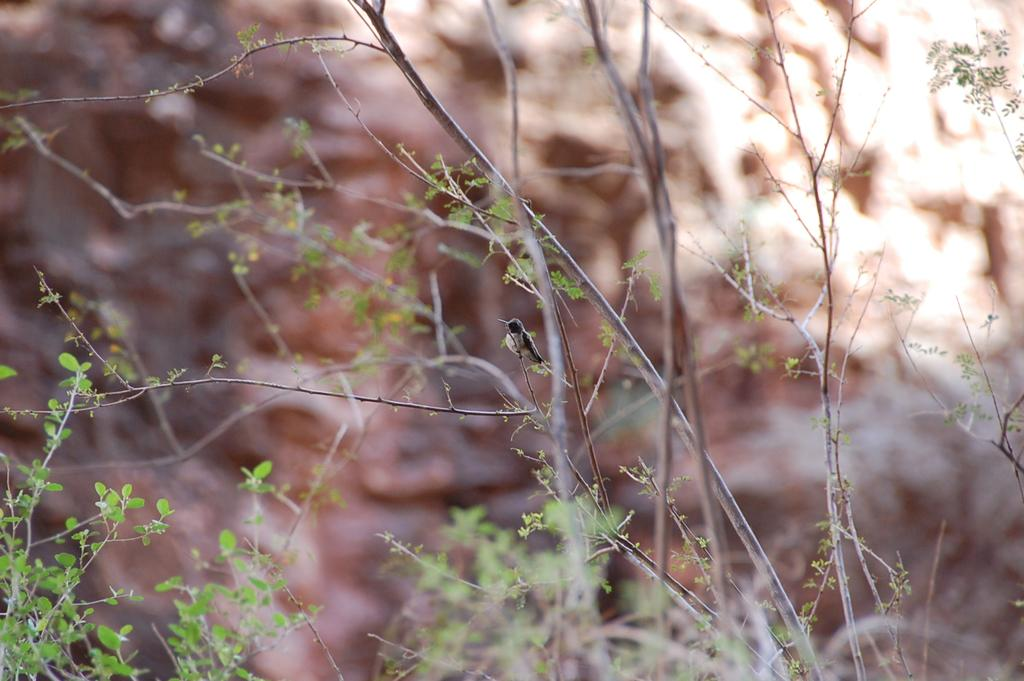What type of animal can be seen in the image? There is a bird on a plant in the image. What else can be seen in the image besides the bird? There are other plants visible in the image. Can you describe the background of the image? The background of the image is blurred. What type of engine can be seen in the image? There is no engine present in the image. What type of lumber is visible in the image? There is no lumber present in the image. 